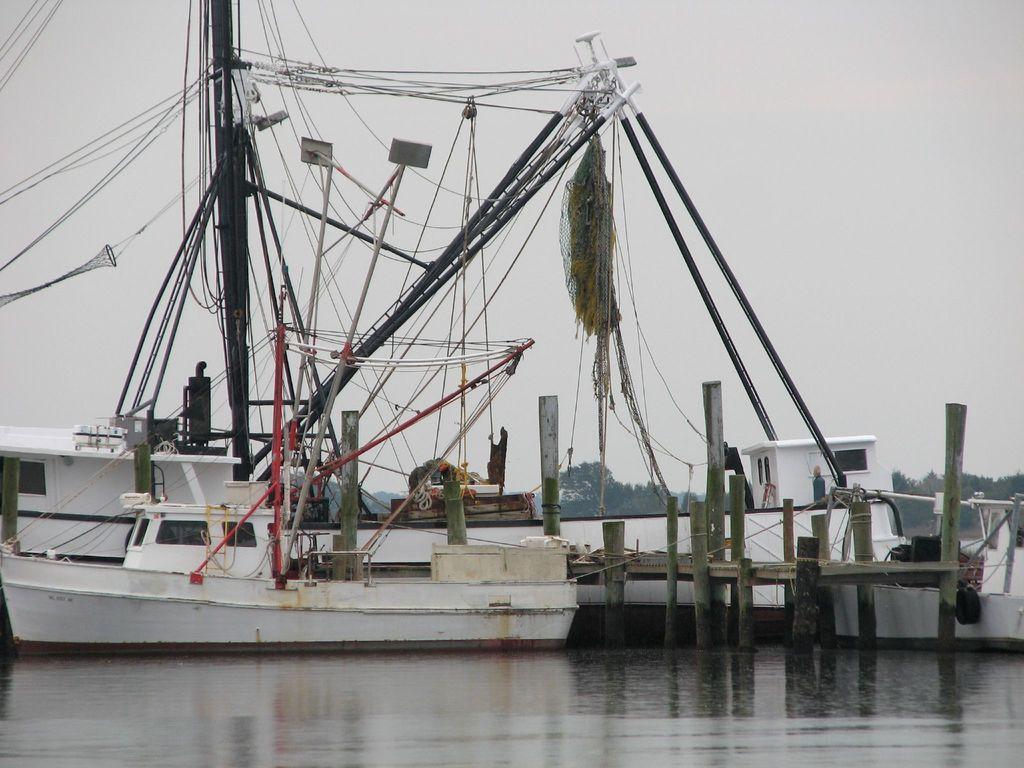Describe this image in one or two sentences. In this picture I can observe boats floating on the water. In the bottom of the picture I can observe water. In the background there are trees and sky. 